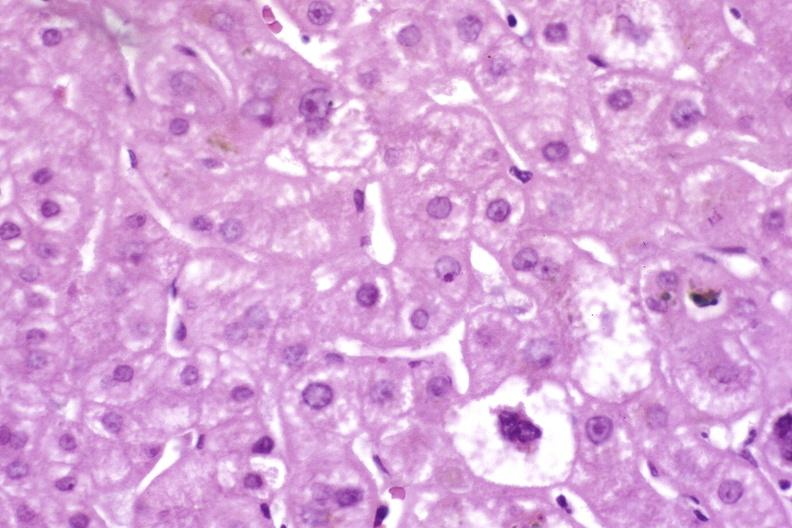does bilobed show resolving acute rejection?
Answer the question using a single word or phrase. No 